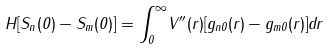<formula> <loc_0><loc_0><loc_500><loc_500>H [ S _ { n } ( 0 ) - S _ { m } ( 0 ) ] = { \int _ { 0 } ^ { \infty } } V ^ { \prime \prime } ( r ) [ g _ { n 0 } ( r ) - g _ { m 0 } ( r ) ] d r</formula> 